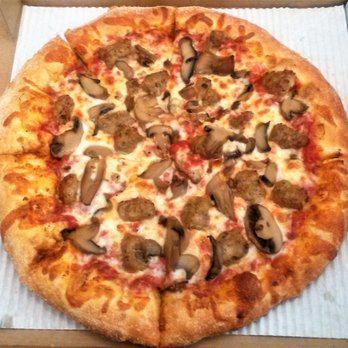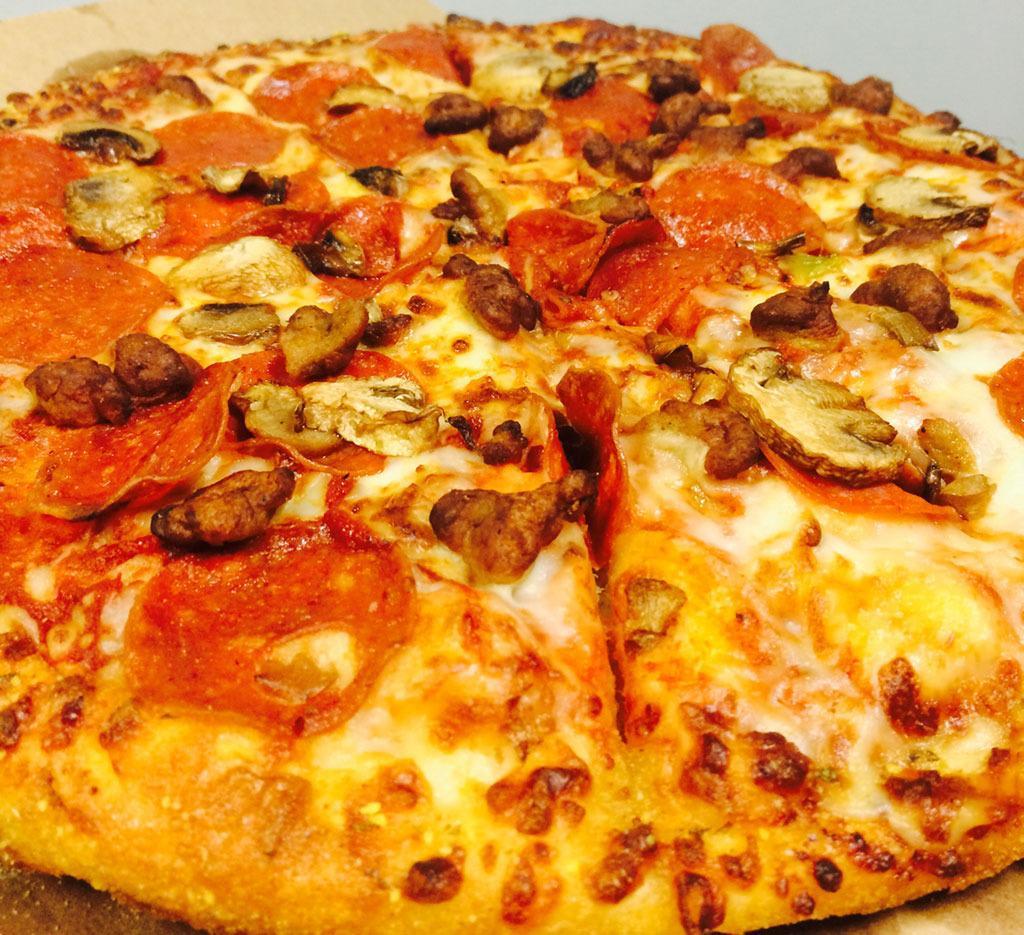The first image is the image on the left, the second image is the image on the right. For the images displayed, is the sentence "A sliced pizza topped with pepperonis and green bits is in an open brown cardboard box in one image." factually correct? Answer yes or no. No. The first image is the image on the left, the second image is the image on the right. Analyze the images presented: Is the assertion "In at least one image there is a a pizza withe pepperoni on each slice that is still in the cardboard box that was delivered." valid? Answer yes or no. No. 